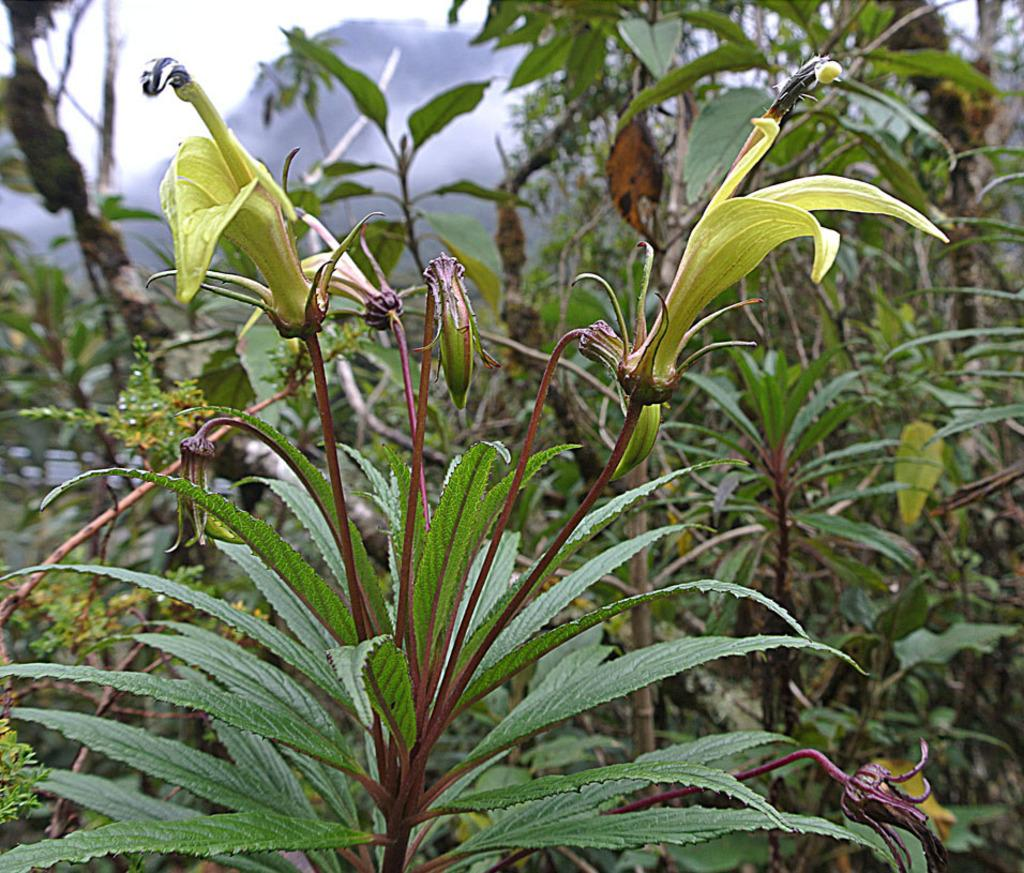What is located in the center of the image? There are plants in the center of the image. Where is the throne located in the image? There is no throne present in the image. Is there an umbrella shading the plants in the image? There is no mention of an umbrella in the image, and the presence of one cannot be confirmed. Can you see any goldfish swimming in the image? There is no mention of goldfish in the image, and the presence of any cannot be confirmed. 